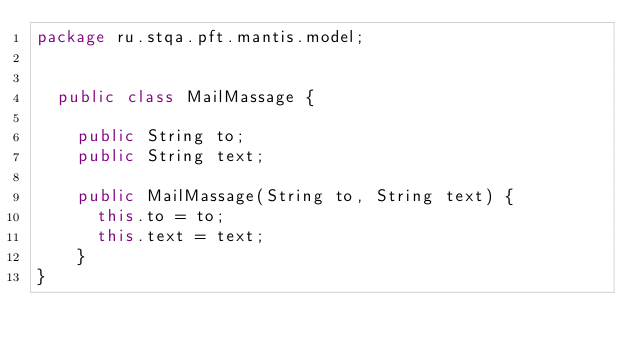<code> <loc_0><loc_0><loc_500><loc_500><_Java_>package ru.stqa.pft.mantis.model;


  public class MailMassage {

    public String to;
    public String text;

    public MailMassage(String to, String text) {
      this.to = to;
      this.text = text;
    }
}
</code> 